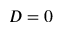<formula> <loc_0><loc_0><loc_500><loc_500>D = 0</formula> 